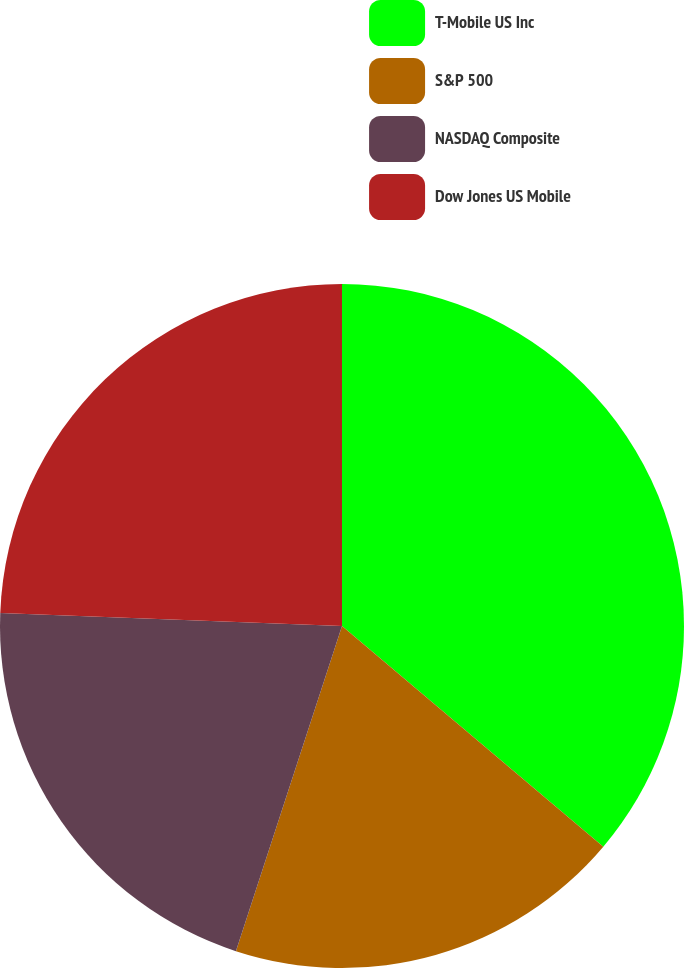<chart> <loc_0><loc_0><loc_500><loc_500><pie_chart><fcel>T-Mobile US Inc<fcel>S&P 500<fcel>NASDAQ Composite<fcel>Dow Jones US Mobile<nl><fcel>36.16%<fcel>18.86%<fcel>20.59%<fcel>24.39%<nl></chart> 